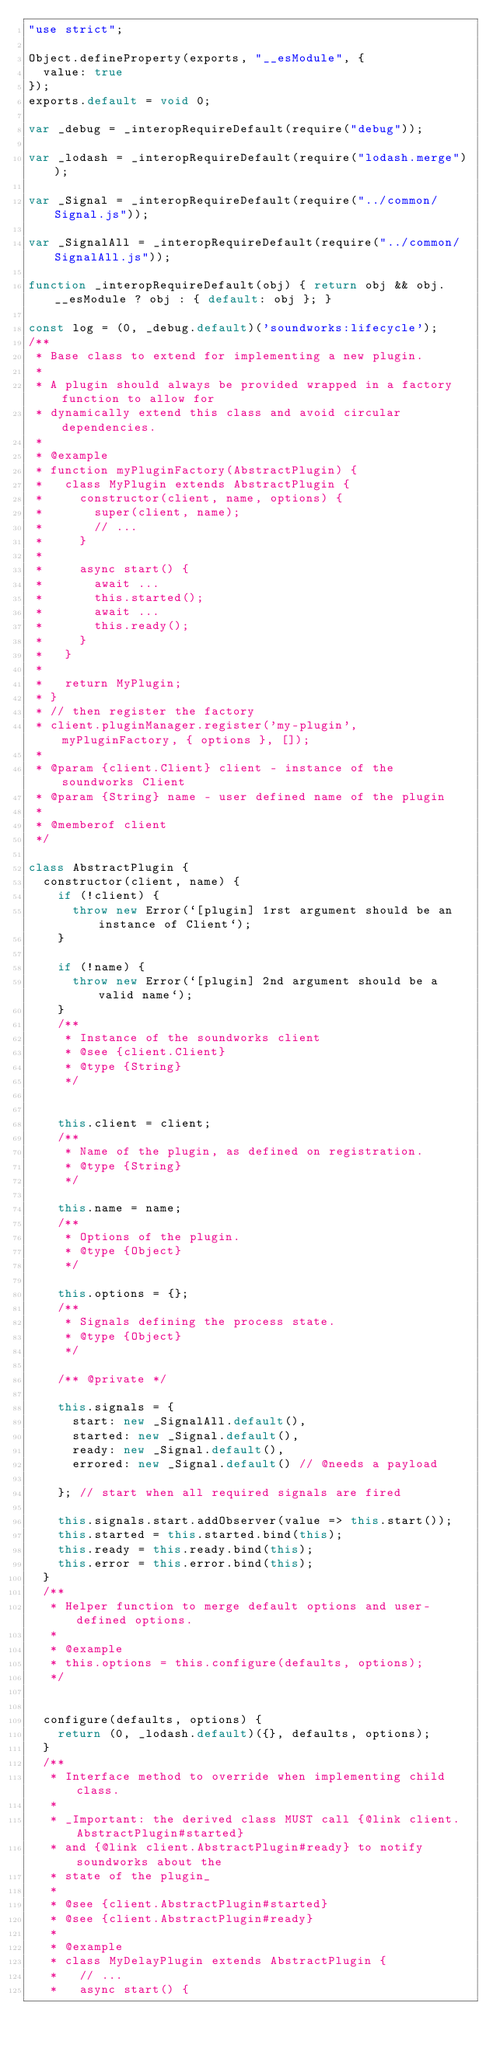<code> <loc_0><loc_0><loc_500><loc_500><_JavaScript_>"use strict";

Object.defineProperty(exports, "__esModule", {
  value: true
});
exports.default = void 0;

var _debug = _interopRequireDefault(require("debug"));

var _lodash = _interopRequireDefault(require("lodash.merge"));

var _Signal = _interopRequireDefault(require("../common/Signal.js"));

var _SignalAll = _interopRequireDefault(require("../common/SignalAll.js"));

function _interopRequireDefault(obj) { return obj && obj.__esModule ? obj : { default: obj }; }

const log = (0, _debug.default)('soundworks:lifecycle');
/**
 * Base class to extend for implementing a new plugin.
 *
 * A plugin should always be provided wrapped in a factory function to allow for
 * dynamically extend this class and avoid circular dependencies.
 *
 * @example
 * function myPluginFactory(AbstractPlugin) {
 *   class MyPlugin extends AbstractPlugin {
 *     constructor(client, name, options) {
 *       super(client, name);
 *       // ...
 *     }
 *
 *     async start() {
 *       await ...
 *       this.started();
 *       await ...
 *       this.ready();
 *     }
 *   }
 *
 *   return MyPlugin;
 * }
 * // then register the factory
 * client.pluginManager.register('my-plugin', myPluginFactory, { options }, []);
 *
 * @param {client.Client} client - instance of the soundworks Client
 * @param {String} name - user defined name of the plugin
 *
 * @memberof client
 */

class AbstractPlugin {
  constructor(client, name) {
    if (!client) {
      throw new Error(`[plugin] 1rst argument should be an instance of Client`);
    }

    if (!name) {
      throw new Error(`[plugin] 2nd argument should be a valid name`);
    }
    /**
     * Instance of the soundworks client
     * @see {client.Client}
     * @type {String}
     */


    this.client = client;
    /**
     * Name of the plugin, as defined on registration.
     * @type {String}
     */

    this.name = name;
    /**
     * Options of the plugin.
     * @type {Object}
     */

    this.options = {};
    /**
     * Signals defining the process state.
     * @type {Object}
     */

    /** @private */

    this.signals = {
      start: new _SignalAll.default(),
      started: new _Signal.default(),
      ready: new _Signal.default(),
      errored: new _Signal.default() // @needs a payload

    }; // start when all required signals are fired

    this.signals.start.addObserver(value => this.start());
    this.started = this.started.bind(this);
    this.ready = this.ready.bind(this);
    this.error = this.error.bind(this);
  }
  /**
   * Helper function to merge default options and user-defined options.
   *
   * @example
   * this.options = this.configure(defaults, options);
   */


  configure(defaults, options) {
    return (0, _lodash.default)({}, defaults, options);
  }
  /**
   * Interface method to override when implementing child class.
   *
   * _Important: the derived class MUST call {@link client.AbstractPlugin#started}
   * and {@link client.AbstractPlugin#ready} to notify soundworks about the
   * state of the plugin_
   *
   * @see {client.AbstractPlugin#started}
   * @see {client.AbstractPlugin#ready}
   *
   * @example
   * class MyDelayPlugin extends AbstractPlugin {
   *   // ...
   *   async start() {</code> 